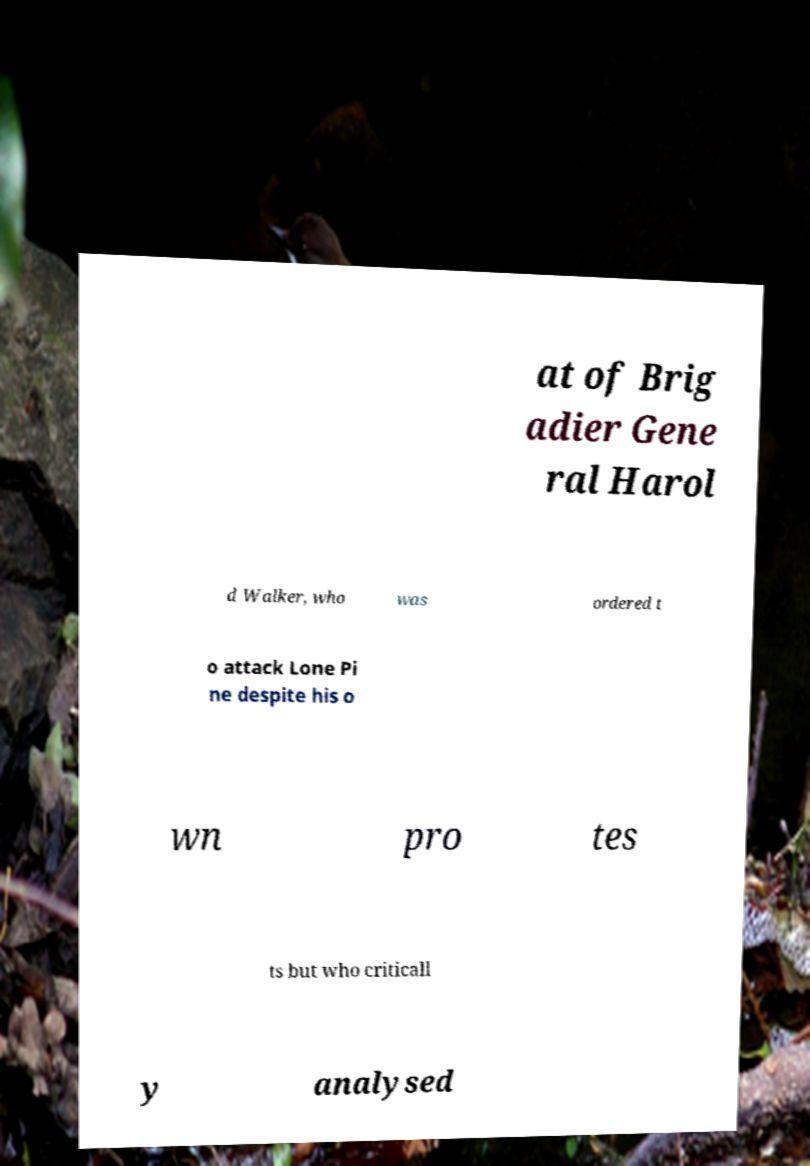There's text embedded in this image that I need extracted. Can you transcribe it verbatim? at of Brig adier Gene ral Harol d Walker, who was ordered t o attack Lone Pi ne despite his o wn pro tes ts but who criticall y analysed 